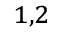<formula> <loc_0><loc_0><loc_500><loc_500>^ { 1 , 2 }</formula> 